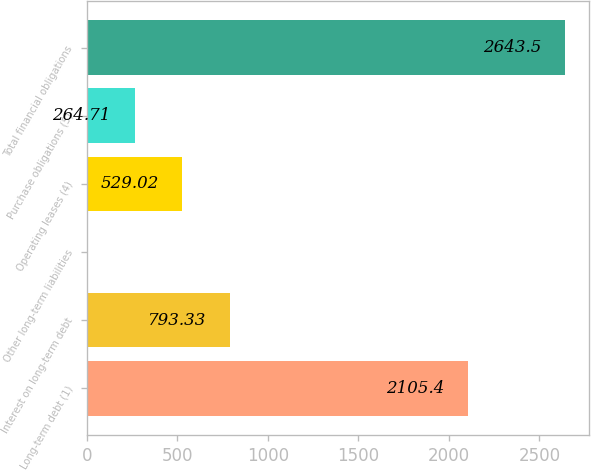Convert chart to OTSL. <chart><loc_0><loc_0><loc_500><loc_500><bar_chart><fcel>Long-term debt (1)<fcel>Interest on long-term debt<fcel>Other long-term liabilities<fcel>Operating leases (4)<fcel>Purchase obligations (5)<fcel>Total financial obligations<nl><fcel>2105.4<fcel>793.33<fcel>0.4<fcel>529.02<fcel>264.71<fcel>2643.5<nl></chart> 